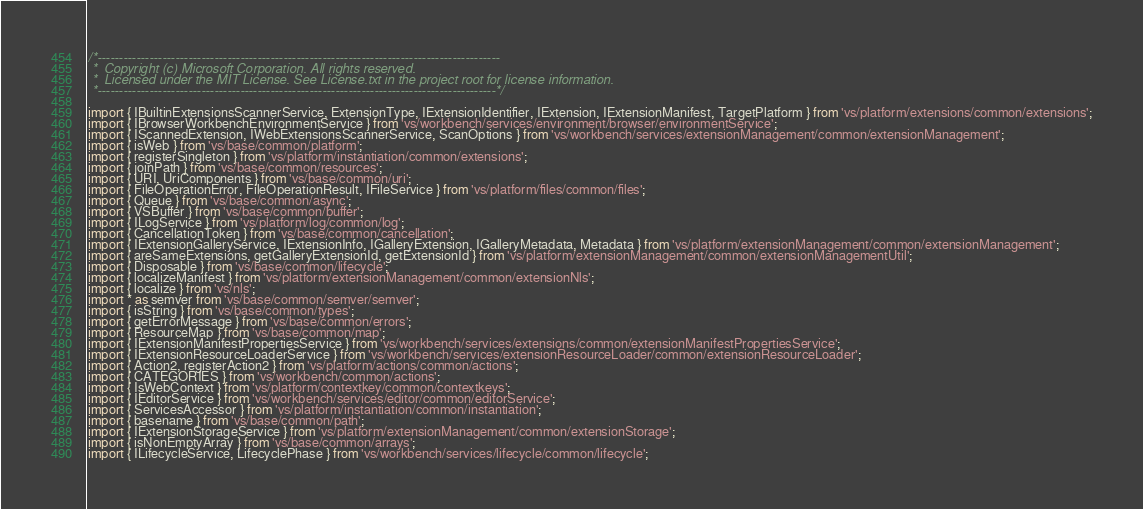Convert code to text. <code><loc_0><loc_0><loc_500><loc_500><_TypeScript_>/*---------------------------------------------------------------------------------------------
 *  Copyright (c) Microsoft Corporation. All rights reserved.
 *  Licensed under the MIT License. See License.txt in the project root for license information.
 *--------------------------------------------------------------------------------------------*/

import { IBuiltinExtensionsScannerService, ExtensionType, IExtensionIdentifier, IExtension, IExtensionManifest, TargetPlatform } from 'vs/platform/extensions/common/extensions';
import { IBrowserWorkbenchEnvironmentService } from 'vs/workbench/services/environment/browser/environmentService';
import { IScannedExtension, IWebExtensionsScannerService, ScanOptions } from 'vs/workbench/services/extensionManagement/common/extensionManagement';
import { isWeb } from 'vs/base/common/platform';
import { registerSingleton } from 'vs/platform/instantiation/common/extensions';
import { joinPath } from 'vs/base/common/resources';
import { URI, UriComponents } from 'vs/base/common/uri';
import { FileOperationError, FileOperationResult, IFileService } from 'vs/platform/files/common/files';
import { Queue } from 'vs/base/common/async';
import { VSBuffer } from 'vs/base/common/buffer';
import { ILogService } from 'vs/platform/log/common/log';
import { CancellationToken } from 'vs/base/common/cancellation';
import { IExtensionGalleryService, IExtensionInfo, IGalleryExtension, IGalleryMetadata, Metadata } from 'vs/platform/extensionManagement/common/extensionManagement';
import { areSameExtensions, getGalleryExtensionId, getExtensionId } from 'vs/platform/extensionManagement/common/extensionManagementUtil';
import { Disposable } from 'vs/base/common/lifecycle';
import { localizeManifest } from 'vs/platform/extensionManagement/common/extensionNls';
import { localize } from 'vs/nls';
import * as semver from 'vs/base/common/semver/semver';
import { isString } from 'vs/base/common/types';
import { getErrorMessage } from 'vs/base/common/errors';
import { ResourceMap } from 'vs/base/common/map';
import { IExtensionManifestPropertiesService } from 'vs/workbench/services/extensions/common/extensionManifestPropertiesService';
import { IExtensionResourceLoaderService } from 'vs/workbench/services/extensionResourceLoader/common/extensionResourceLoader';
import { Action2, registerAction2 } from 'vs/platform/actions/common/actions';
import { CATEGORIES } from 'vs/workbench/common/actions';
import { IsWebContext } from 'vs/platform/contextkey/common/contextkeys';
import { IEditorService } from 'vs/workbench/services/editor/common/editorService';
import { ServicesAccessor } from 'vs/platform/instantiation/common/instantiation';
import { basename } from 'vs/base/common/path';
import { IExtensionStorageService } from 'vs/platform/extensionManagement/common/extensionStorage';
import { isNonEmptyArray } from 'vs/base/common/arrays';
import { ILifecycleService, LifecyclePhase } from 'vs/workbench/services/lifecycle/common/lifecycle';</code> 